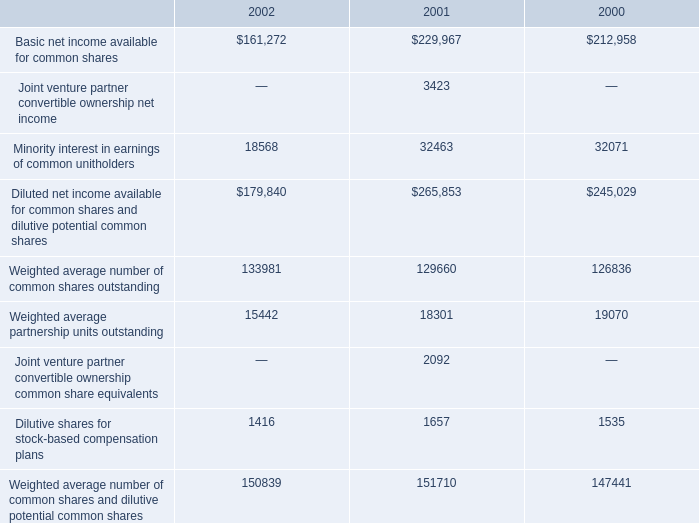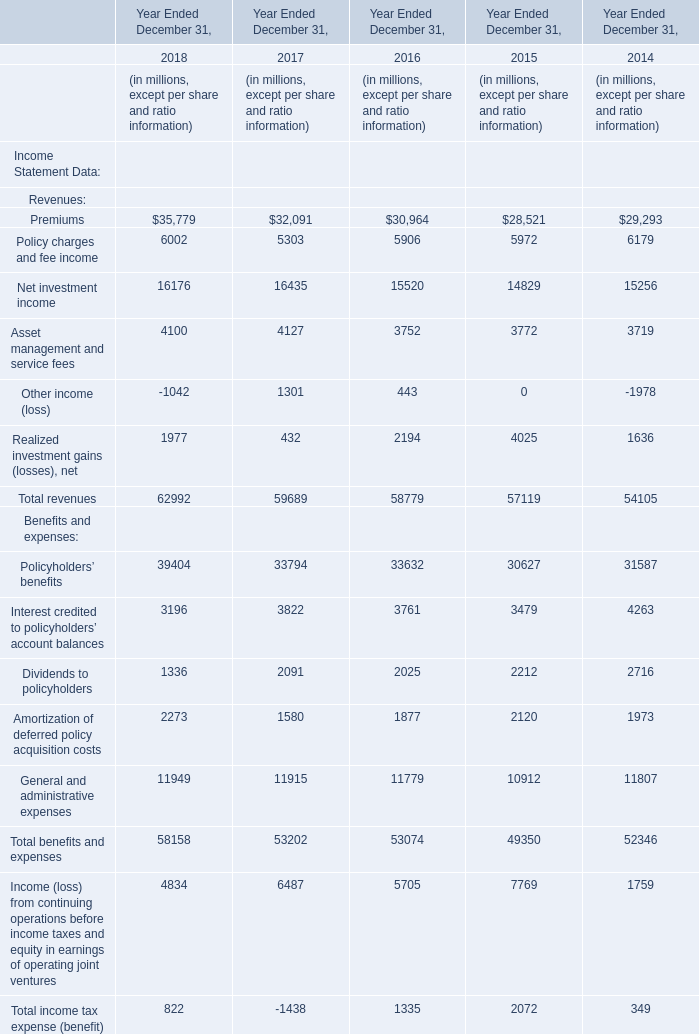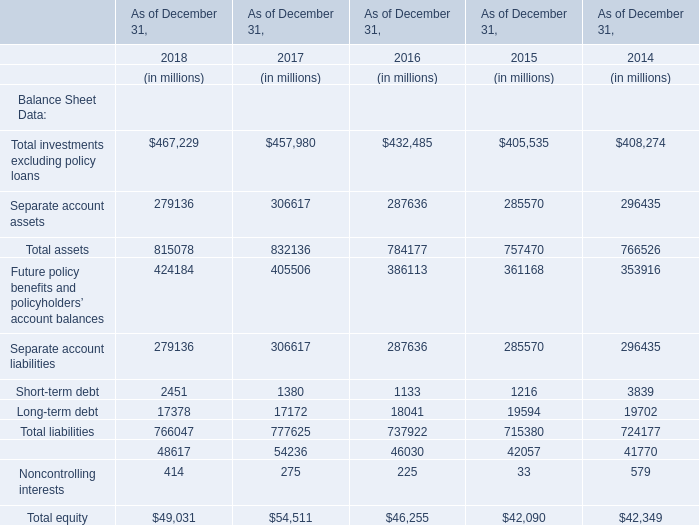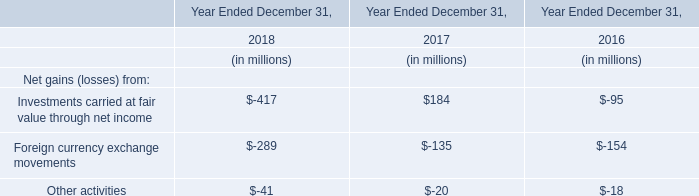the weighted average number of common shares outstanding comprises what percent of weighted average number of common shares and dilutive potential common shares in the year 2001? 
Computations: ((129660 / 151710) * 100)
Answer: 85.46569. 